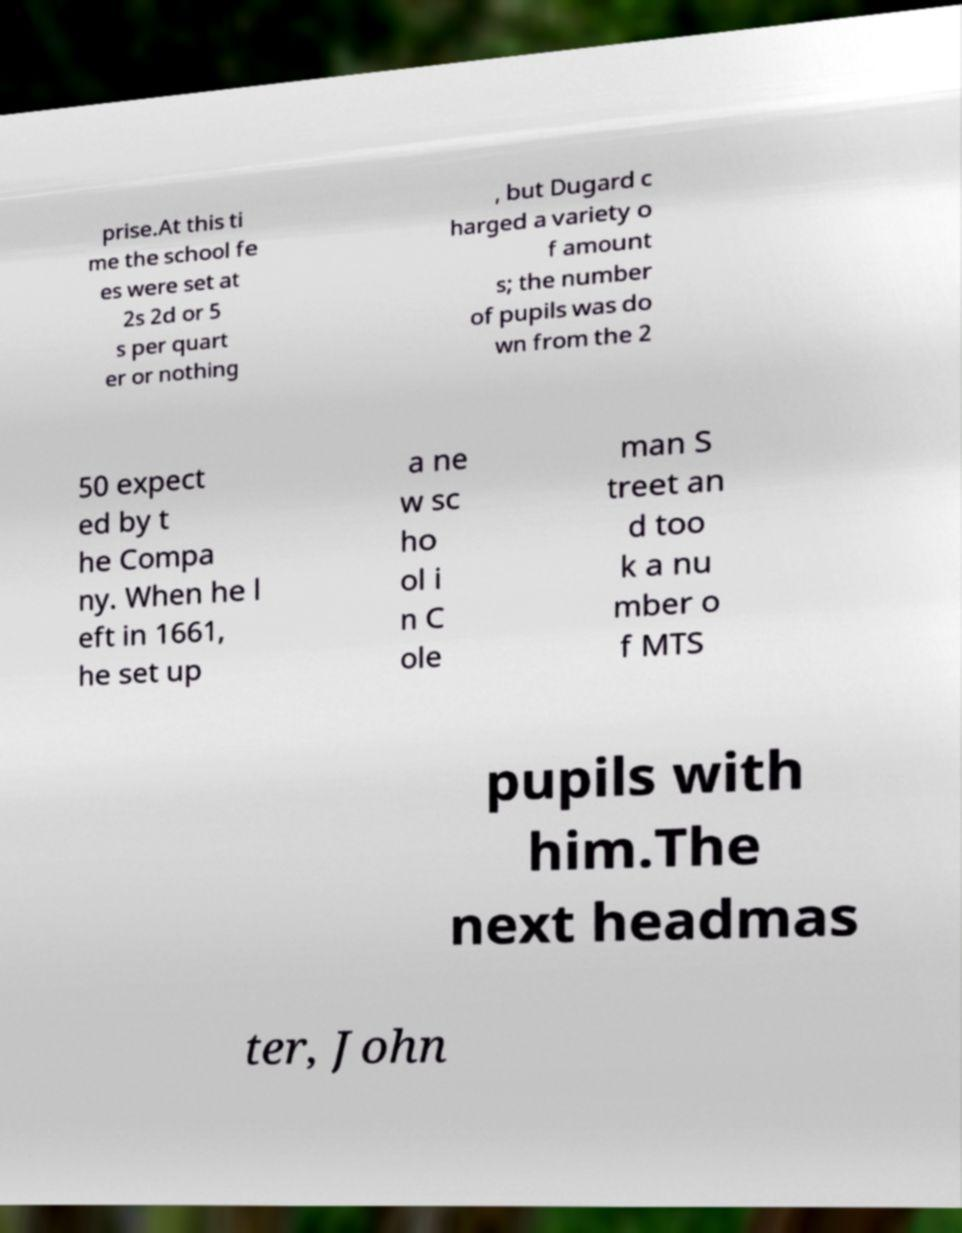Could you assist in decoding the text presented in this image and type it out clearly? prise.At this ti me the school fe es were set at 2s 2d or 5 s per quart er or nothing , but Dugard c harged a variety o f amount s; the number of pupils was do wn from the 2 50 expect ed by t he Compa ny. When he l eft in 1661, he set up a ne w sc ho ol i n C ole man S treet an d too k a nu mber o f MTS pupils with him.The next headmas ter, John 